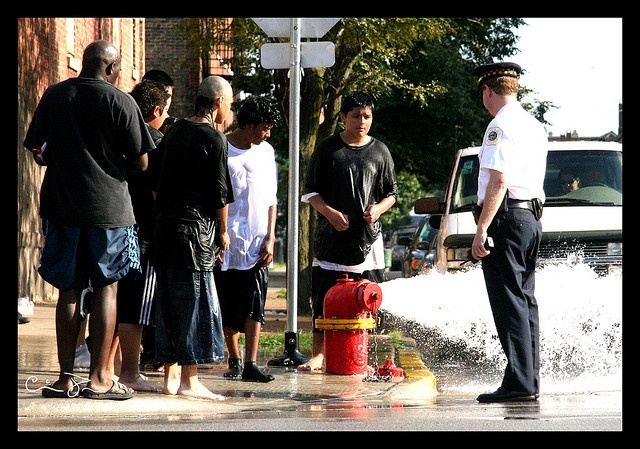Describe the objects in this image and their specific colors. I can see people in black, gray, and darkgray tones, people in black, ivory, gray, and darkgray tones, people in black, white, gray, and brown tones, truck in black, white, gray, and darkgray tones, and people in black, ivory, maroon, and gray tones in this image. 